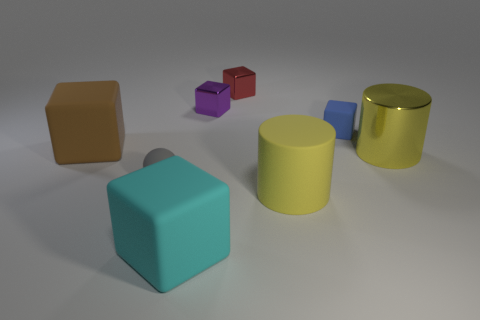Is the shape of the small purple shiny thing the same as the brown rubber object?
Keep it short and to the point. Yes. How big is the matte cube that is in front of the brown cube?
Your answer should be very brief. Large. There is a purple block that is made of the same material as the small red thing; what size is it?
Provide a short and direct response. Small. Are there fewer metal cubes than small cyan matte objects?
Ensure brevity in your answer.  No. There is a red block that is the same size as the purple metal thing; what material is it?
Your response must be concise. Metal. Is the number of small purple metallic cubes greater than the number of tiny green metal cylinders?
Make the answer very short. Yes. How many other objects are there of the same color as the tiny ball?
Offer a very short reply. 0. What number of blocks are both behind the big metallic cylinder and to the left of the small blue thing?
Keep it short and to the point. 3. Are there more large rubber blocks in front of the brown rubber thing than big yellow cylinders in front of the cyan object?
Ensure brevity in your answer.  Yes. There is a brown block that is to the left of the small red shiny cube; what is it made of?
Your response must be concise. Rubber. 